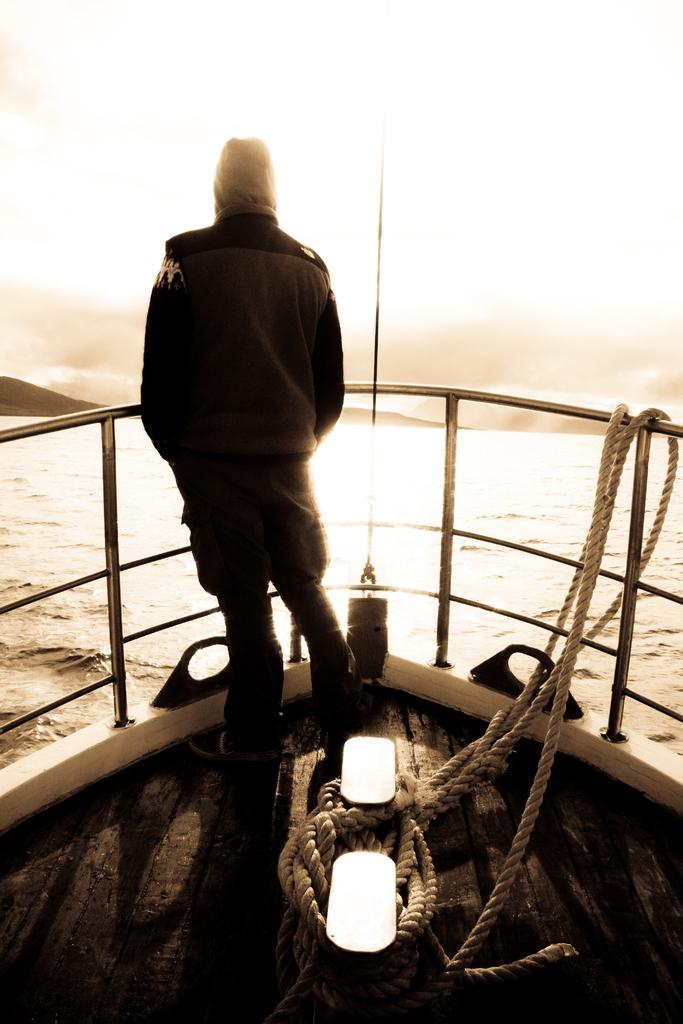Describe this image in one or two sentences. In this given picture, I can see a water, sky, a person standing in a boat, rope, two lights. 